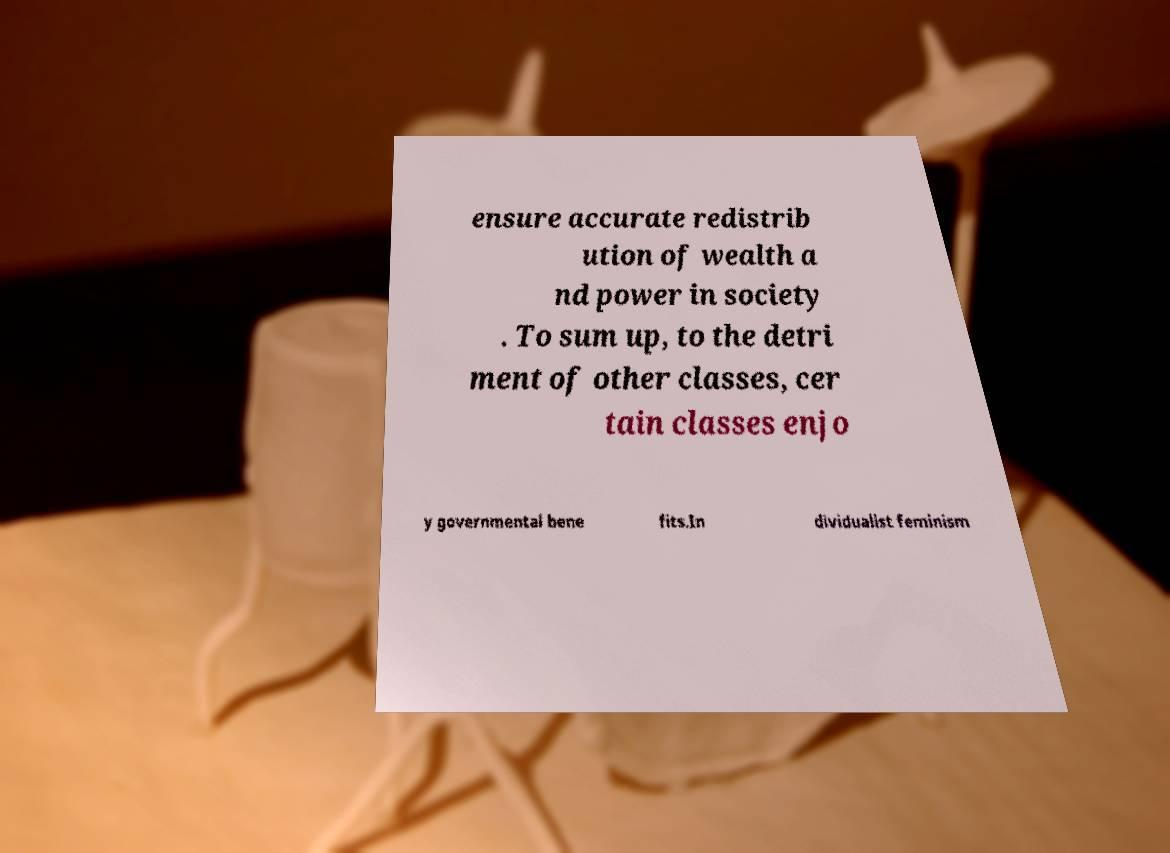What messages or text are displayed in this image? I need them in a readable, typed format. ensure accurate redistrib ution of wealth a nd power in society . To sum up, to the detri ment of other classes, cer tain classes enjo y governmental bene fits.In dividualist feminism 